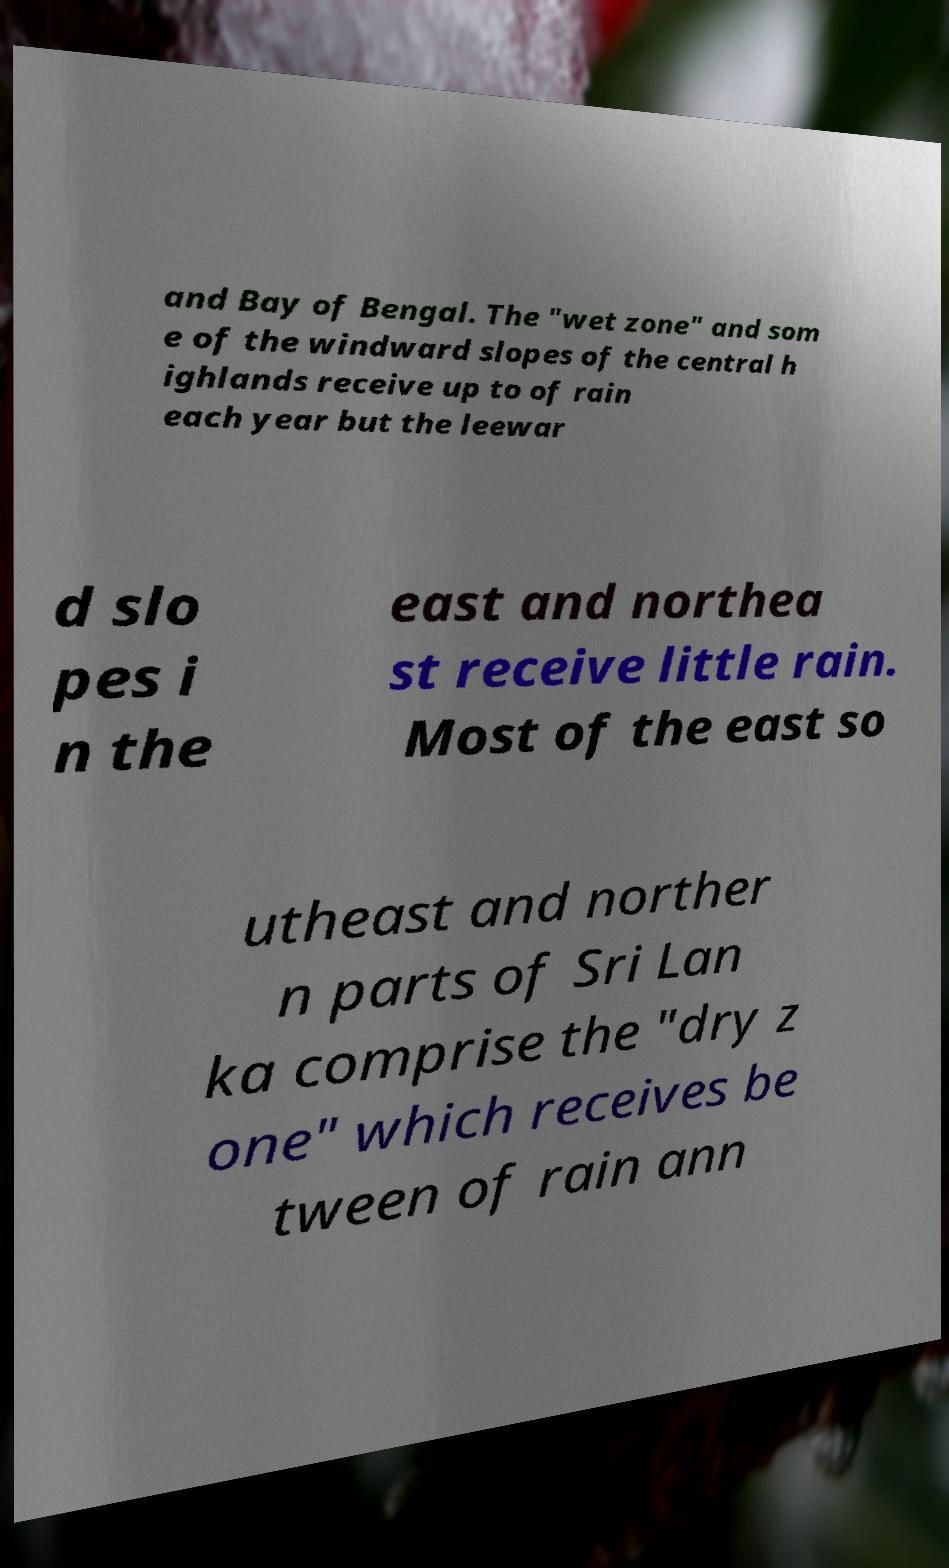There's text embedded in this image that I need extracted. Can you transcribe it verbatim? and Bay of Bengal. The "wet zone" and som e of the windward slopes of the central h ighlands receive up to of rain each year but the leewar d slo pes i n the east and northea st receive little rain. Most of the east so utheast and norther n parts of Sri Lan ka comprise the "dry z one" which receives be tween of rain ann 